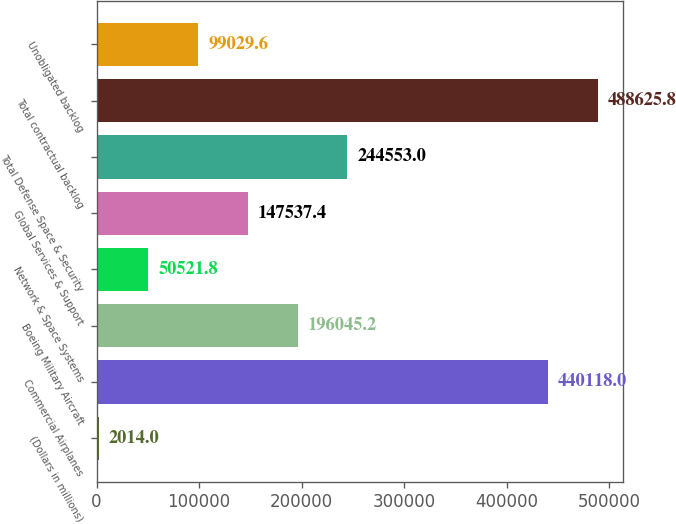Convert chart to OTSL. <chart><loc_0><loc_0><loc_500><loc_500><bar_chart><fcel>(Dollars in millions)<fcel>Commercial Airplanes<fcel>Boeing Military Aircraft<fcel>Network & Space Systems<fcel>Global Services & Support<fcel>Total Defense Space & Security<fcel>Total contractual backlog<fcel>Unobligated backlog<nl><fcel>2014<fcel>440118<fcel>196045<fcel>50521.8<fcel>147537<fcel>244553<fcel>488626<fcel>99029.6<nl></chart> 